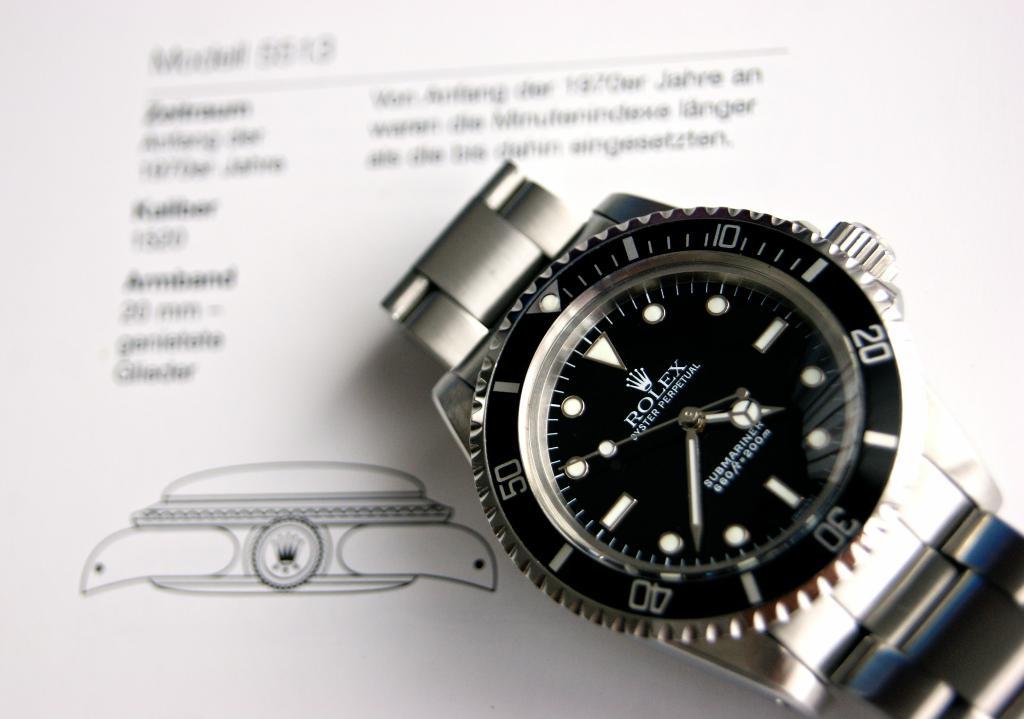What time is on the watch?
Ensure brevity in your answer.  4:38. What brand is this watch?
Provide a short and direct response. Rolex. 